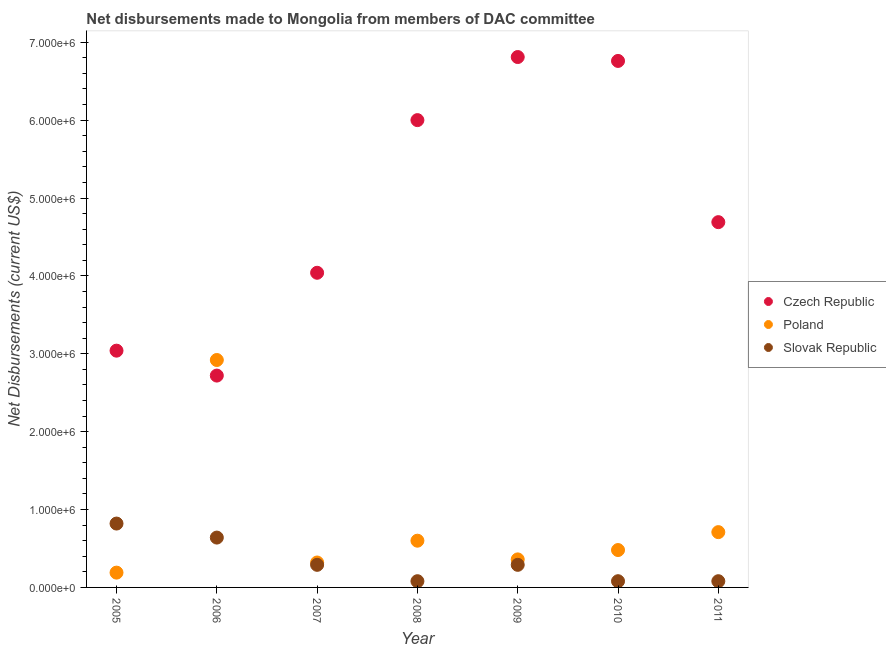How many different coloured dotlines are there?
Your answer should be very brief. 3. What is the net disbursements made by czech republic in 2007?
Keep it short and to the point. 4.04e+06. Across all years, what is the maximum net disbursements made by poland?
Provide a succinct answer. 2.92e+06. Across all years, what is the minimum net disbursements made by slovak republic?
Offer a very short reply. 8.00e+04. In which year was the net disbursements made by slovak republic minimum?
Keep it short and to the point. 2008. What is the total net disbursements made by poland in the graph?
Make the answer very short. 5.58e+06. What is the difference between the net disbursements made by slovak republic in 2009 and that in 2010?
Your answer should be compact. 2.10e+05. What is the difference between the net disbursements made by poland in 2010 and the net disbursements made by czech republic in 2008?
Make the answer very short. -5.52e+06. What is the average net disbursements made by poland per year?
Make the answer very short. 7.97e+05. In the year 2005, what is the difference between the net disbursements made by czech republic and net disbursements made by poland?
Make the answer very short. 2.85e+06. In how many years, is the net disbursements made by slovak republic greater than 3000000 US$?
Provide a short and direct response. 0. What is the ratio of the net disbursements made by slovak republic in 2008 to that in 2009?
Offer a terse response. 0.28. Is the net disbursements made by poland in 2006 less than that in 2009?
Ensure brevity in your answer.  No. What is the difference between the highest and the second highest net disbursements made by slovak republic?
Offer a very short reply. 1.80e+05. What is the difference between the highest and the lowest net disbursements made by czech republic?
Your answer should be very brief. 4.09e+06. In how many years, is the net disbursements made by slovak republic greater than the average net disbursements made by slovak republic taken over all years?
Your response must be concise. 2. Is the sum of the net disbursements made by czech republic in 2007 and 2011 greater than the maximum net disbursements made by slovak republic across all years?
Provide a short and direct response. Yes. Is it the case that in every year, the sum of the net disbursements made by czech republic and net disbursements made by poland is greater than the net disbursements made by slovak republic?
Your response must be concise. Yes. Is the net disbursements made by poland strictly less than the net disbursements made by czech republic over the years?
Give a very brief answer. No. How many years are there in the graph?
Provide a short and direct response. 7. What is the difference between two consecutive major ticks on the Y-axis?
Offer a terse response. 1.00e+06. Does the graph contain grids?
Ensure brevity in your answer.  No. How many legend labels are there?
Keep it short and to the point. 3. What is the title of the graph?
Ensure brevity in your answer.  Net disbursements made to Mongolia from members of DAC committee. Does "Ages 20-60" appear as one of the legend labels in the graph?
Ensure brevity in your answer.  No. What is the label or title of the X-axis?
Your answer should be compact. Year. What is the label or title of the Y-axis?
Provide a succinct answer. Net Disbursements (current US$). What is the Net Disbursements (current US$) of Czech Republic in 2005?
Provide a succinct answer. 3.04e+06. What is the Net Disbursements (current US$) in Slovak Republic in 2005?
Make the answer very short. 8.20e+05. What is the Net Disbursements (current US$) in Czech Republic in 2006?
Ensure brevity in your answer.  2.72e+06. What is the Net Disbursements (current US$) of Poland in 2006?
Your answer should be compact. 2.92e+06. What is the Net Disbursements (current US$) in Slovak Republic in 2006?
Your answer should be compact. 6.40e+05. What is the Net Disbursements (current US$) of Czech Republic in 2007?
Your response must be concise. 4.04e+06. What is the Net Disbursements (current US$) of Poland in 2007?
Give a very brief answer. 3.20e+05. What is the Net Disbursements (current US$) of Slovak Republic in 2007?
Keep it short and to the point. 2.90e+05. What is the Net Disbursements (current US$) in Czech Republic in 2008?
Offer a terse response. 6.00e+06. What is the Net Disbursements (current US$) in Poland in 2008?
Your answer should be compact. 6.00e+05. What is the Net Disbursements (current US$) in Slovak Republic in 2008?
Keep it short and to the point. 8.00e+04. What is the Net Disbursements (current US$) in Czech Republic in 2009?
Ensure brevity in your answer.  6.81e+06. What is the Net Disbursements (current US$) in Slovak Republic in 2009?
Offer a very short reply. 2.90e+05. What is the Net Disbursements (current US$) of Czech Republic in 2010?
Your answer should be compact. 6.76e+06. What is the Net Disbursements (current US$) in Poland in 2010?
Give a very brief answer. 4.80e+05. What is the Net Disbursements (current US$) in Slovak Republic in 2010?
Give a very brief answer. 8.00e+04. What is the Net Disbursements (current US$) of Czech Republic in 2011?
Your answer should be very brief. 4.69e+06. What is the Net Disbursements (current US$) of Poland in 2011?
Offer a very short reply. 7.10e+05. What is the Net Disbursements (current US$) of Slovak Republic in 2011?
Provide a succinct answer. 8.00e+04. Across all years, what is the maximum Net Disbursements (current US$) of Czech Republic?
Keep it short and to the point. 6.81e+06. Across all years, what is the maximum Net Disbursements (current US$) in Poland?
Offer a terse response. 2.92e+06. Across all years, what is the maximum Net Disbursements (current US$) in Slovak Republic?
Make the answer very short. 8.20e+05. Across all years, what is the minimum Net Disbursements (current US$) in Czech Republic?
Your answer should be compact. 2.72e+06. What is the total Net Disbursements (current US$) in Czech Republic in the graph?
Your response must be concise. 3.41e+07. What is the total Net Disbursements (current US$) in Poland in the graph?
Your response must be concise. 5.58e+06. What is the total Net Disbursements (current US$) in Slovak Republic in the graph?
Provide a succinct answer. 2.28e+06. What is the difference between the Net Disbursements (current US$) in Poland in 2005 and that in 2006?
Keep it short and to the point. -2.73e+06. What is the difference between the Net Disbursements (current US$) in Poland in 2005 and that in 2007?
Ensure brevity in your answer.  -1.30e+05. What is the difference between the Net Disbursements (current US$) in Slovak Republic in 2005 and that in 2007?
Make the answer very short. 5.30e+05. What is the difference between the Net Disbursements (current US$) in Czech Republic in 2005 and that in 2008?
Provide a succinct answer. -2.96e+06. What is the difference between the Net Disbursements (current US$) in Poland in 2005 and that in 2008?
Offer a very short reply. -4.10e+05. What is the difference between the Net Disbursements (current US$) in Slovak Republic in 2005 and that in 2008?
Your answer should be very brief. 7.40e+05. What is the difference between the Net Disbursements (current US$) of Czech Republic in 2005 and that in 2009?
Offer a terse response. -3.77e+06. What is the difference between the Net Disbursements (current US$) in Poland in 2005 and that in 2009?
Offer a very short reply. -1.70e+05. What is the difference between the Net Disbursements (current US$) in Slovak Republic in 2005 and that in 2009?
Your response must be concise. 5.30e+05. What is the difference between the Net Disbursements (current US$) of Czech Republic in 2005 and that in 2010?
Provide a short and direct response. -3.72e+06. What is the difference between the Net Disbursements (current US$) in Slovak Republic in 2005 and that in 2010?
Offer a terse response. 7.40e+05. What is the difference between the Net Disbursements (current US$) of Czech Republic in 2005 and that in 2011?
Offer a terse response. -1.65e+06. What is the difference between the Net Disbursements (current US$) in Poland in 2005 and that in 2011?
Your response must be concise. -5.20e+05. What is the difference between the Net Disbursements (current US$) of Slovak Republic in 2005 and that in 2011?
Offer a very short reply. 7.40e+05. What is the difference between the Net Disbursements (current US$) of Czech Republic in 2006 and that in 2007?
Offer a terse response. -1.32e+06. What is the difference between the Net Disbursements (current US$) of Poland in 2006 and that in 2007?
Provide a short and direct response. 2.60e+06. What is the difference between the Net Disbursements (current US$) in Czech Republic in 2006 and that in 2008?
Ensure brevity in your answer.  -3.28e+06. What is the difference between the Net Disbursements (current US$) in Poland in 2006 and that in 2008?
Give a very brief answer. 2.32e+06. What is the difference between the Net Disbursements (current US$) in Slovak Republic in 2006 and that in 2008?
Offer a terse response. 5.60e+05. What is the difference between the Net Disbursements (current US$) of Czech Republic in 2006 and that in 2009?
Offer a very short reply. -4.09e+06. What is the difference between the Net Disbursements (current US$) in Poland in 2006 and that in 2009?
Provide a succinct answer. 2.56e+06. What is the difference between the Net Disbursements (current US$) in Slovak Republic in 2006 and that in 2009?
Provide a succinct answer. 3.50e+05. What is the difference between the Net Disbursements (current US$) of Czech Republic in 2006 and that in 2010?
Give a very brief answer. -4.04e+06. What is the difference between the Net Disbursements (current US$) in Poland in 2006 and that in 2010?
Your answer should be compact. 2.44e+06. What is the difference between the Net Disbursements (current US$) in Slovak Republic in 2006 and that in 2010?
Give a very brief answer. 5.60e+05. What is the difference between the Net Disbursements (current US$) of Czech Republic in 2006 and that in 2011?
Provide a succinct answer. -1.97e+06. What is the difference between the Net Disbursements (current US$) in Poland in 2006 and that in 2011?
Your answer should be compact. 2.21e+06. What is the difference between the Net Disbursements (current US$) in Slovak Republic in 2006 and that in 2011?
Offer a very short reply. 5.60e+05. What is the difference between the Net Disbursements (current US$) in Czech Republic in 2007 and that in 2008?
Your response must be concise. -1.96e+06. What is the difference between the Net Disbursements (current US$) of Poland in 2007 and that in 2008?
Give a very brief answer. -2.80e+05. What is the difference between the Net Disbursements (current US$) in Slovak Republic in 2007 and that in 2008?
Your answer should be compact. 2.10e+05. What is the difference between the Net Disbursements (current US$) in Czech Republic in 2007 and that in 2009?
Make the answer very short. -2.77e+06. What is the difference between the Net Disbursements (current US$) in Slovak Republic in 2007 and that in 2009?
Your answer should be compact. 0. What is the difference between the Net Disbursements (current US$) in Czech Republic in 2007 and that in 2010?
Your response must be concise. -2.72e+06. What is the difference between the Net Disbursements (current US$) of Slovak Republic in 2007 and that in 2010?
Give a very brief answer. 2.10e+05. What is the difference between the Net Disbursements (current US$) in Czech Republic in 2007 and that in 2011?
Your response must be concise. -6.50e+05. What is the difference between the Net Disbursements (current US$) in Poland in 2007 and that in 2011?
Provide a short and direct response. -3.90e+05. What is the difference between the Net Disbursements (current US$) of Czech Republic in 2008 and that in 2009?
Your response must be concise. -8.10e+05. What is the difference between the Net Disbursements (current US$) in Poland in 2008 and that in 2009?
Offer a terse response. 2.40e+05. What is the difference between the Net Disbursements (current US$) of Czech Republic in 2008 and that in 2010?
Provide a short and direct response. -7.60e+05. What is the difference between the Net Disbursements (current US$) of Czech Republic in 2008 and that in 2011?
Your answer should be very brief. 1.31e+06. What is the difference between the Net Disbursements (current US$) of Czech Republic in 2009 and that in 2011?
Your answer should be very brief. 2.12e+06. What is the difference between the Net Disbursements (current US$) of Poland in 2009 and that in 2011?
Give a very brief answer. -3.50e+05. What is the difference between the Net Disbursements (current US$) of Slovak Republic in 2009 and that in 2011?
Make the answer very short. 2.10e+05. What is the difference between the Net Disbursements (current US$) in Czech Republic in 2010 and that in 2011?
Offer a very short reply. 2.07e+06. What is the difference between the Net Disbursements (current US$) of Poland in 2010 and that in 2011?
Keep it short and to the point. -2.30e+05. What is the difference between the Net Disbursements (current US$) of Slovak Republic in 2010 and that in 2011?
Your response must be concise. 0. What is the difference between the Net Disbursements (current US$) in Czech Republic in 2005 and the Net Disbursements (current US$) in Slovak Republic in 2006?
Give a very brief answer. 2.40e+06. What is the difference between the Net Disbursements (current US$) in Poland in 2005 and the Net Disbursements (current US$) in Slovak Republic in 2006?
Offer a terse response. -4.50e+05. What is the difference between the Net Disbursements (current US$) in Czech Republic in 2005 and the Net Disbursements (current US$) in Poland in 2007?
Provide a succinct answer. 2.72e+06. What is the difference between the Net Disbursements (current US$) of Czech Republic in 2005 and the Net Disbursements (current US$) of Slovak Republic in 2007?
Your answer should be compact. 2.75e+06. What is the difference between the Net Disbursements (current US$) in Poland in 2005 and the Net Disbursements (current US$) in Slovak Republic in 2007?
Make the answer very short. -1.00e+05. What is the difference between the Net Disbursements (current US$) in Czech Republic in 2005 and the Net Disbursements (current US$) in Poland in 2008?
Give a very brief answer. 2.44e+06. What is the difference between the Net Disbursements (current US$) of Czech Republic in 2005 and the Net Disbursements (current US$) of Slovak Republic in 2008?
Give a very brief answer. 2.96e+06. What is the difference between the Net Disbursements (current US$) of Poland in 2005 and the Net Disbursements (current US$) of Slovak Republic in 2008?
Offer a very short reply. 1.10e+05. What is the difference between the Net Disbursements (current US$) of Czech Republic in 2005 and the Net Disbursements (current US$) of Poland in 2009?
Give a very brief answer. 2.68e+06. What is the difference between the Net Disbursements (current US$) of Czech Republic in 2005 and the Net Disbursements (current US$) of Slovak Republic in 2009?
Your answer should be compact. 2.75e+06. What is the difference between the Net Disbursements (current US$) of Poland in 2005 and the Net Disbursements (current US$) of Slovak Republic in 2009?
Ensure brevity in your answer.  -1.00e+05. What is the difference between the Net Disbursements (current US$) in Czech Republic in 2005 and the Net Disbursements (current US$) in Poland in 2010?
Offer a very short reply. 2.56e+06. What is the difference between the Net Disbursements (current US$) of Czech Republic in 2005 and the Net Disbursements (current US$) of Slovak Republic in 2010?
Offer a terse response. 2.96e+06. What is the difference between the Net Disbursements (current US$) in Poland in 2005 and the Net Disbursements (current US$) in Slovak Republic in 2010?
Your answer should be very brief. 1.10e+05. What is the difference between the Net Disbursements (current US$) of Czech Republic in 2005 and the Net Disbursements (current US$) of Poland in 2011?
Your answer should be very brief. 2.33e+06. What is the difference between the Net Disbursements (current US$) in Czech Republic in 2005 and the Net Disbursements (current US$) in Slovak Republic in 2011?
Your answer should be very brief. 2.96e+06. What is the difference between the Net Disbursements (current US$) of Poland in 2005 and the Net Disbursements (current US$) of Slovak Republic in 2011?
Offer a very short reply. 1.10e+05. What is the difference between the Net Disbursements (current US$) in Czech Republic in 2006 and the Net Disbursements (current US$) in Poland in 2007?
Your answer should be compact. 2.40e+06. What is the difference between the Net Disbursements (current US$) in Czech Republic in 2006 and the Net Disbursements (current US$) in Slovak Republic in 2007?
Provide a short and direct response. 2.43e+06. What is the difference between the Net Disbursements (current US$) of Poland in 2006 and the Net Disbursements (current US$) of Slovak Republic in 2007?
Give a very brief answer. 2.63e+06. What is the difference between the Net Disbursements (current US$) in Czech Republic in 2006 and the Net Disbursements (current US$) in Poland in 2008?
Offer a very short reply. 2.12e+06. What is the difference between the Net Disbursements (current US$) of Czech Republic in 2006 and the Net Disbursements (current US$) of Slovak Republic in 2008?
Your response must be concise. 2.64e+06. What is the difference between the Net Disbursements (current US$) of Poland in 2006 and the Net Disbursements (current US$) of Slovak Republic in 2008?
Provide a succinct answer. 2.84e+06. What is the difference between the Net Disbursements (current US$) of Czech Republic in 2006 and the Net Disbursements (current US$) of Poland in 2009?
Make the answer very short. 2.36e+06. What is the difference between the Net Disbursements (current US$) of Czech Republic in 2006 and the Net Disbursements (current US$) of Slovak Republic in 2009?
Ensure brevity in your answer.  2.43e+06. What is the difference between the Net Disbursements (current US$) in Poland in 2006 and the Net Disbursements (current US$) in Slovak Republic in 2009?
Make the answer very short. 2.63e+06. What is the difference between the Net Disbursements (current US$) in Czech Republic in 2006 and the Net Disbursements (current US$) in Poland in 2010?
Give a very brief answer. 2.24e+06. What is the difference between the Net Disbursements (current US$) of Czech Republic in 2006 and the Net Disbursements (current US$) of Slovak Republic in 2010?
Your response must be concise. 2.64e+06. What is the difference between the Net Disbursements (current US$) of Poland in 2006 and the Net Disbursements (current US$) of Slovak Republic in 2010?
Give a very brief answer. 2.84e+06. What is the difference between the Net Disbursements (current US$) of Czech Republic in 2006 and the Net Disbursements (current US$) of Poland in 2011?
Make the answer very short. 2.01e+06. What is the difference between the Net Disbursements (current US$) in Czech Republic in 2006 and the Net Disbursements (current US$) in Slovak Republic in 2011?
Offer a very short reply. 2.64e+06. What is the difference between the Net Disbursements (current US$) of Poland in 2006 and the Net Disbursements (current US$) of Slovak Republic in 2011?
Offer a very short reply. 2.84e+06. What is the difference between the Net Disbursements (current US$) of Czech Republic in 2007 and the Net Disbursements (current US$) of Poland in 2008?
Provide a succinct answer. 3.44e+06. What is the difference between the Net Disbursements (current US$) in Czech Republic in 2007 and the Net Disbursements (current US$) in Slovak Republic in 2008?
Your answer should be very brief. 3.96e+06. What is the difference between the Net Disbursements (current US$) of Czech Republic in 2007 and the Net Disbursements (current US$) of Poland in 2009?
Keep it short and to the point. 3.68e+06. What is the difference between the Net Disbursements (current US$) in Czech Republic in 2007 and the Net Disbursements (current US$) in Slovak Republic in 2009?
Give a very brief answer. 3.75e+06. What is the difference between the Net Disbursements (current US$) of Poland in 2007 and the Net Disbursements (current US$) of Slovak Republic in 2009?
Offer a very short reply. 3.00e+04. What is the difference between the Net Disbursements (current US$) of Czech Republic in 2007 and the Net Disbursements (current US$) of Poland in 2010?
Your answer should be very brief. 3.56e+06. What is the difference between the Net Disbursements (current US$) of Czech Republic in 2007 and the Net Disbursements (current US$) of Slovak Republic in 2010?
Your answer should be very brief. 3.96e+06. What is the difference between the Net Disbursements (current US$) of Czech Republic in 2007 and the Net Disbursements (current US$) of Poland in 2011?
Offer a very short reply. 3.33e+06. What is the difference between the Net Disbursements (current US$) in Czech Republic in 2007 and the Net Disbursements (current US$) in Slovak Republic in 2011?
Your answer should be compact. 3.96e+06. What is the difference between the Net Disbursements (current US$) of Czech Republic in 2008 and the Net Disbursements (current US$) of Poland in 2009?
Keep it short and to the point. 5.64e+06. What is the difference between the Net Disbursements (current US$) in Czech Republic in 2008 and the Net Disbursements (current US$) in Slovak Republic in 2009?
Provide a short and direct response. 5.71e+06. What is the difference between the Net Disbursements (current US$) in Czech Republic in 2008 and the Net Disbursements (current US$) in Poland in 2010?
Your answer should be very brief. 5.52e+06. What is the difference between the Net Disbursements (current US$) of Czech Republic in 2008 and the Net Disbursements (current US$) of Slovak Republic in 2010?
Make the answer very short. 5.92e+06. What is the difference between the Net Disbursements (current US$) of Poland in 2008 and the Net Disbursements (current US$) of Slovak Republic in 2010?
Give a very brief answer. 5.20e+05. What is the difference between the Net Disbursements (current US$) in Czech Republic in 2008 and the Net Disbursements (current US$) in Poland in 2011?
Offer a very short reply. 5.29e+06. What is the difference between the Net Disbursements (current US$) in Czech Republic in 2008 and the Net Disbursements (current US$) in Slovak Republic in 2011?
Give a very brief answer. 5.92e+06. What is the difference between the Net Disbursements (current US$) in Poland in 2008 and the Net Disbursements (current US$) in Slovak Republic in 2011?
Ensure brevity in your answer.  5.20e+05. What is the difference between the Net Disbursements (current US$) in Czech Republic in 2009 and the Net Disbursements (current US$) in Poland in 2010?
Provide a succinct answer. 6.33e+06. What is the difference between the Net Disbursements (current US$) of Czech Republic in 2009 and the Net Disbursements (current US$) of Slovak Republic in 2010?
Offer a very short reply. 6.73e+06. What is the difference between the Net Disbursements (current US$) in Poland in 2009 and the Net Disbursements (current US$) in Slovak Republic in 2010?
Your response must be concise. 2.80e+05. What is the difference between the Net Disbursements (current US$) in Czech Republic in 2009 and the Net Disbursements (current US$) in Poland in 2011?
Offer a terse response. 6.10e+06. What is the difference between the Net Disbursements (current US$) in Czech Republic in 2009 and the Net Disbursements (current US$) in Slovak Republic in 2011?
Provide a succinct answer. 6.73e+06. What is the difference between the Net Disbursements (current US$) in Czech Republic in 2010 and the Net Disbursements (current US$) in Poland in 2011?
Your response must be concise. 6.05e+06. What is the difference between the Net Disbursements (current US$) in Czech Republic in 2010 and the Net Disbursements (current US$) in Slovak Republic in 2011?
Give a very brief answer. 6.68e+06. What is the average Net Disbursements (current US$) in Czech Republic per year?
Keep it short and to the point. 4.87e+06. What is the average Net Disbursements (current US$) in Poland per year?
Give a very brief answer. 7.97e+05. What is the average Net Disbursements (current US$) of Slovak Republic per year?
Make the answer very short. 3.26e+05. In the year 2005, what is the difference between the Net Disbursements (current US$) of Czech Republic and Net Disbursements (current US$) of Poland?
Keep it short and to the point. 2.85e+06. In the year 2005, what is the difference between the Net Disbursements (current US$) in Czech Republic and Net Disbursements (current US$) in Slovak Republic?
Make the answer very short. 2.22e+06. In the year 2005, what is the difference between the Net Disbursements (current US$) in Poland and Net Disbursements (current US$) in Slovak Republic?
Your answer should be very brief. -6.30e+05. In the year 2006, what is the difference between the Net Disbursements (current US$) of Czech Republic and Net Disbursements (current US$) of Slovak Republic?
Ensure brevity in your answer.  2.08e+06. In the year 2006, what is the difference between the Net Disbursements (current US$) of Poland and Net Disbursements (current US$) of Slovak Republic?
Your answer should be very brief. 2.28e+06. In the year 2007, what is the difference between the Net Disbursements (current US$) of Czech Republic and Net Disbursements (current US$) of Poland?
Make the answer very short. 3.72e+06. In the year 2007, what is the difference between the Net Disbursements (current US$) of Czech Republic and Net Disbursements (current US$) of Slovak Republic?
Provide a succinct answer. 3.75e+06. In the year 2007, what is the difference between the Net Disbursements (current US$) of Poland and Net Disbursements (current US$) of Slovak Republic?
Provide a succinct answer. 3.00e+04. In the year 2008, what is the difference between the Net Disbursements (current US$) in Czech Republic and Net Disbursements (current US$) in Poland?
Offer a very short reply. 5.40e+06. In the year 2008, what is the difference between the Net Disbursements (current US$) in Czech Republic and Net Disbursements (current US$) in Slovak Republic?
Offer a terse response. 5.92e+06. In the year 2008, what is the difference between the Net Disbursements (current US$) of Poland and Net Disbursements (current US$) of Slovak Republic?
Ensure brevity in your answer.  5.20e+05. In the year 2009, what is the difference between the Net Disbursements (current US$) in Czech Republic and Net Disbursements (current US$) in Poland?
Offer a terse response. 6.45e+06. In the year 2009, what is the difference between the Net Disbursements (current US$) of Czech Republic and Net Disbursements (current US$) of Slovak Republic?
Your answer should be very brief. 6.52e+06. In the year 2009, what is the difference between the Net Disbursements (current US$) in Poland and Net Disbursements (current US$) in Slovak Republic?
Your response must be concise. 7.00e+04. In the year 2010, what is the difference between the Net Disbursements (current US$) of Czech Republic and Net Disbursements (current US$) of Poland?
Your answer should be compact. 6.28e+06. In the year 2010, what is the difference between the Net Disbursements (current US$) of Czech Republic and Net Disbursements (current US$) of Slovak Republic?
Make the answer very short. 6.68e+06. In the year 2010, what is the difference between the Net Disbursements (current US$) of Poland and Net Disbursements (current US$) of Slovak Republic?
Provide a succinct answer. 4.00e+05. In the year 2011, what is the difference between the Net Disbursements (current US$) of Czech Republic and Net Disbursements (current US$) of Poland?
Your response must be concise. 3.98e+06. In the year 2011, what is the difference between the Net Disbursements (current US$) of Czech Republic and Net Disbursements (current US$) of Slovak Republic?
Make the answer very short. 4.61e+06. In the year 2011, what is the difference between the Net Disbursements (current US$) in Poland and Net Disbursements (current US$) in Slovak Republic?
Keep it short and to the point. 6.30e+05. What is the ratio of the Net Disbursements (current US$) in Czech Republic in 2005 to that in 2006?
Your response must be concise. 1.12. What is the ratio of the Net Disbursements (current US$) of Poland in 2005 to that in 2006?
Provide a succinct answer. 0.07. What is the ratio of the Net Disbursements (current US$) in Slovak Republic in 2005 to that in 2006?
Keep it short and to the point. 1.28. What is the ratio of the Net Disbursements (current US$) in Czech Republic in 2005 to that in 2007?
Give a very brief answer. 0.75. What is the ratio of the Net Disbursements (current US$) of Poland in 2005 to that in 2007?
Offer a terse response. 0.59. What is the ratio of the Net Disbursements (current US$) of Slovak Republic in 2005 to that in 2007?
Keep it short and to the point. 2.83. What is the ratio of the Net Disbursements (current US$) in Czech Republic in 2005 to that in 2008?
Your answer should be very brief. 0.51. What is the ratio of the Net Disbursements (current US$) in Poland in 2005 to that in 2008?
Provide a short and direct response. 0.32. What is the ratio of the Net Disbursements (current US$) in Slovak Republic in 2005 to that in 2008?
Offer a very short reply. 10.25. What is the ratio of the Net Disbursements (current US$) in Czech Republic in 2005 to that in 2009?
Your response must be concise. 0.45. What is the ratio of the Net Disbursements (current US$) in Poland in 2005 to that in 2009?
Ensure brevity in your answer.  0.53. What is the ratio of the Net Disbursements (current US$) of Slovak Republic in 2005 to that in 2009?
Your response must be concise. 2.83. What is the ratio of the Net Disbursements (current US$) in Czech Republic in 2005 to that in 2010?
Your answer should be compact. 0.45. What is the ratio of the Net Disbursements (current US$) of Poland in 2005 to that in 2010?
Provide a short and direct response. 0.4. What is the ratio of the Net Disbursements (current US$) in Slovak Republic in 2005 to that in 2010?
Ensure brevity in your answer.  10.25. What is the ratio of the Net Disbursements (current US$) of Czech Republic in 2005 to that in 2011?
Offer a very short reply. 0.65. What is the ratio of the Net Disbursements (current US$) in Poland in 2005 to that in 2011?
Give a very brief answer. 0.27. What is the ratio of the Net Disbursements (current US$) in Slovak Republic in 2005 to that in 2011?
Give a very brief answer. 10.25. What is the ratio of the Net Disbursements (current US$) in Czech Republic in 2006 to that in 2007?
Offer a very short reply. 0.67. What is the ratio of the Net Disbursements (current US$) of Poland in 2006 to that in 2007?
Keep it short and to the point. 9.12. What is the ratio of the Net Disbursements (current US$) in Slovak Republic in 2006 to that in 2007?
Provide a short and direct response. 2.21. What is the ratio of the Net Disbursements (current US$) in Czech Republic in 2006 to that in 2008?
Your response must be concise. 0.45. What is the ratio of the Net Disbursements (current US$) in Poland in 2006 to that in 2008?
Make the answer very short. 4.87. What is the ratio of the Net Disbursements (current US$) in Slovak Republic in 2006 to that in 2008?
Offer a terse response. 8. What is the ratio of the Net Disbursements (current US$) in Czech Republic in 2006 to that in 2009?
Offer a very short reply. 0.4. What is the ratio of the Net Disbursements (current US$) in Poland in 2006 to that in 2009?
Offer a terse response. 8.11. What is the ratio of the Net Disbursements (current US$) of Slovak Republic in 2006 to that in 2009?
Provide a succinct answer. 2.21. What is the ratio of the Net Disbursements (current US$) in Czech Republic in 2006 to that in 2010?
Offer a very short reply. 0.4. What is the ratio of the Net Disbursements (current US$) in Poland in 2006 to that in 2010?
Your answer should be very brief. 6.08. What is the ratio of the Net Disbursements (current US$) of Czech Republic in 2006 to that in 2011?
Offer a very short reply. 0.58. What is the ratio of the Net Disbursements (current US$) of Poland in 2006 to that in 2011?
Offer a terse response. 4.11. What is the ratio of the Net Disbursements (current US$) in Czech Republic in 2007 to that in 2008?
Your answer should be very brief. 0.67. What is the ratio of the Net Disbursements (current US$) in Poland in 2007 to that in 2008?
Offer a terse response. 0.53. What is the ratio of the Net Disbursements (current US$) in Slovak Republic in 2007 to that in 2008?
Your answer should be very brief. 3.62. What is the ratio of the Net Disbursements (current US$) in Czech Republic in 2007 to that in 2009?
Offer a terse response. 0.59. What is the ratio of the Net Disbursements (current US$) of Czech Republic in 2007 to that in 2010?
Your response must be concise. 0.6. What is the ratio of the Net Disbursements (current US$) in Slovak Republic in 2007 to that in 2010?
Ensure brevity in your answer.  3.62. What is the ratio of the Net Disbursements (current US$) of Czech Republic in 2007 to that in 2011?
Give a very brief answer. 0.86. What is the ratio of the Net Disbursements (current US$) of Poland in 2007 to that in 2011?
Give a very brief answer. 0.45. What is the ratio of the Net Disbursements (current US$) of Slovak Republic in 2007 to that in 2011?
Offer a terse response. 3.62. What is the ratio of the Net Disbursements (current US$) of Czech Republic in 2008 to that in 2009?
Your answer should be very brief. 0.88. What is the ratio of the Net Disbursements (current US$) of Slovak Republic in 2008 to that in 2009?
Ensure brevity in your answer.  0.28. What is the ratio of the Net Disbursements (current US$) in Czech Republic in 2008 to that in 2010?
Make the answer very short. 0.89. What is the ratio of the Net Disbursements (current US$) in Slovak Republic in 2008 to that in 2010?
Ensure brevity in your answer.  1. What is the ratio of the Net Disbursements (current US$) of Czech Republic in 2008 to that in 2011?
Your answer should be very brief. 1.28. What is the ratio of the Net Disbursements (current US$) of Poland in 2008 to that in 2011?
Ensure brevity in your answer.  0.85. What is the ratio of the Net Disbursements (current US$) of Czech Republic in 2009 to that in 2010?
Your answer should be compact. 1.01. What is the ratio of the Net Disbursements (current US$) of Slovak Republic in 2009 to that in 2010?
Give a very brief answer. 3.62. What is the ratio of the Net Disbursements (current US$) of Czech Republic in 2009 to that in 2011?
Offer a very short reply. 1.45. What is the ratio of the Net Disbursements (current US$) in Poland in 2009 to that in 2011?
Your answer should be very brief. 0.51. What is the ratio of the Net Disbursements (current US$) of Slovak Republic in 2009 to that in 2011?
Your response must be concise. 3.62. What is the ratio of the Net Disbursements (current US$) in Czech Republic in 2010 to that in 2011?
Keep it short and to the point. 1.44. What is the ratio of the Net Disbursements (current US$) of Poland in 2010 to that in 2011?
Ensure brevity in your answer.  0.68. What is the difference between the highest and the second highest Net Disbursements (current US$) in Poland?
Provide a short and direct response. 2.21e+06. What is the difference between the highest and the second highest Net Disbursements (current US$) in Slovak Republic?
Make the answer very short. 1.80e+05. What is the difference between the highest and the lowest Net Disbursements (current US$) of Czech Republic?
Offer a very short reply. 4.09e+06. What is the difference between the highest and the lowest Net Disbursements (current US$) of Poland?
Give a very brief answer. 2.73e+06. What is the difference between the highest and the lowest Net Disbursements (current US$) in Slovak Republic?
Keep it short and to the point. 7.40e+05. 